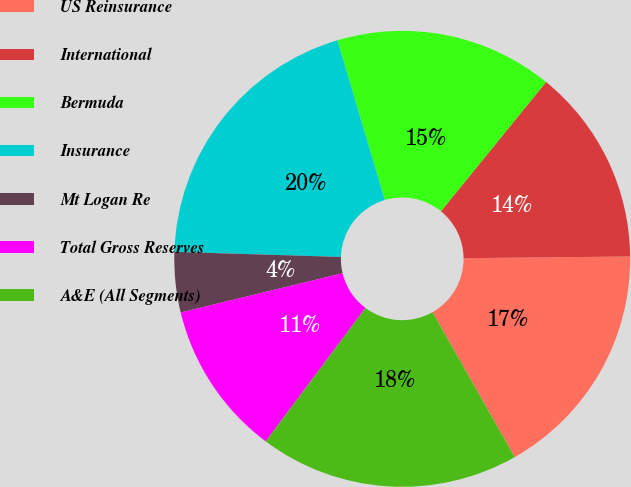Convert chart. <chart><loc_0><loc_0><loc_500><loc_500><pie_chart><fcel>US Reinsurance<fcel>International<fcel>Bermuda<fcel>Insurance<fcel>Mt Logan Re<fcel>Total Gross Reserves<fcel>A&E (All Segments)<nl><fcel>16.95%<fcel>13.97%<fcel>15.46%<fcel>19.92%<fcel>4.27%<fcel>11.0%<fcel>18.43%<nl></chart> 